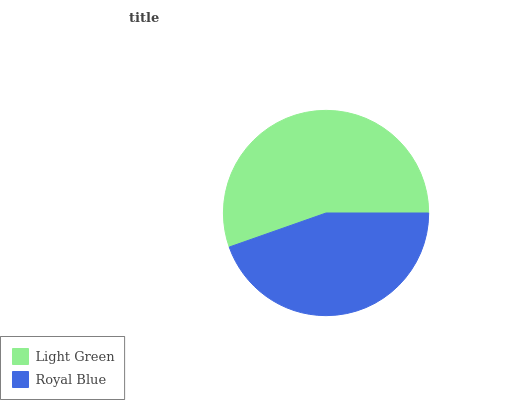Is Royal Blue the minimum?
Answer yes or no. Yes. Is Light Green the maximum?
Answer yes or no. Yes. Is Royal Blue the maximum?
Answer yes or no. No. Is Light Green greater than Royal Blue?
Answer yes or no. Yes. Is Royal Blue less than Light Green?
Answer yes or no. Yes. Is Royal Blue greater than Light Green?
Answer yes or no. No. Is Light Green less than Royal Blue?
Answer yes or no. No. Is Light Green the high median?
Answer yes or no. Yes. Is Royal Blue the low median?
Answer yes or no. Yes. Is Royal Blue the high median?
Answer yes or no. No. Is Light Green the low median?
Answer yes or no. No. 